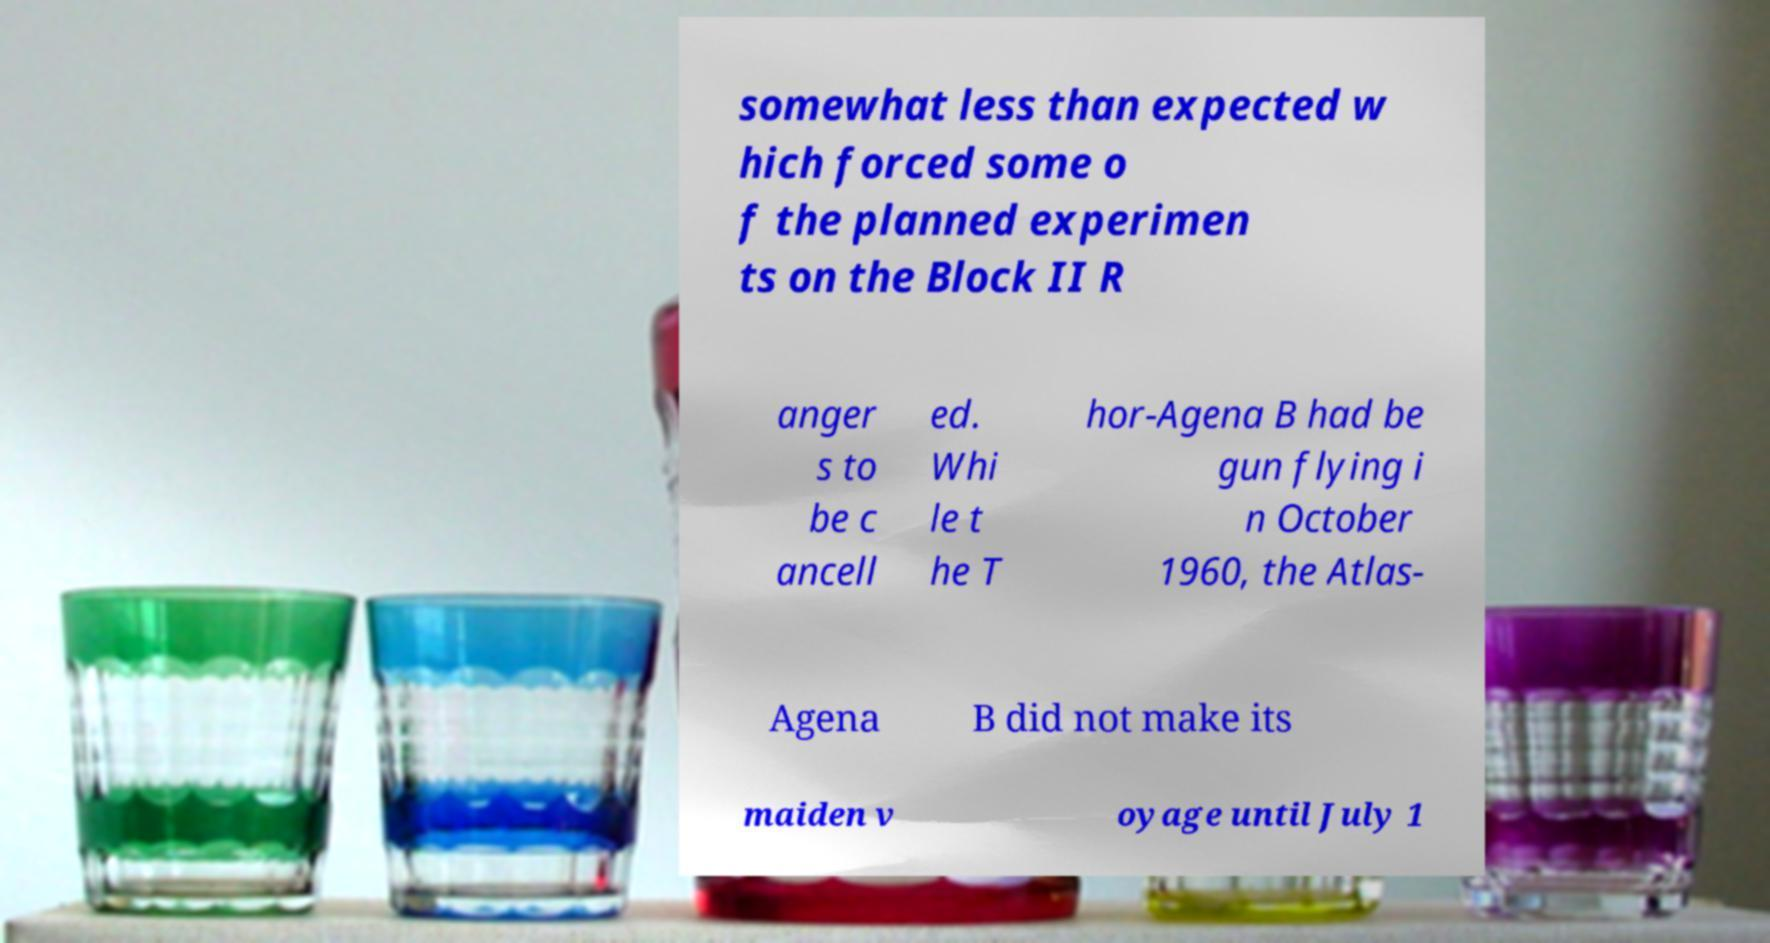Could you extract and type out the text from this image? somewhat less than expected w hich forced some o f the planned experimen ts on the Block II R anger s to be c ancell ed. Whi le t he T hor-Agena B had be gun flying i n October 1960, the Atlas- Agena B did not make its maiden v oyage until July 1 